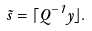Convert formula to latex. <formula><loc_0><loc_0><loc_500><loc_500>\tilde { s } = \lceil Q ^ { - 1 } y \rfloor .</formula> 